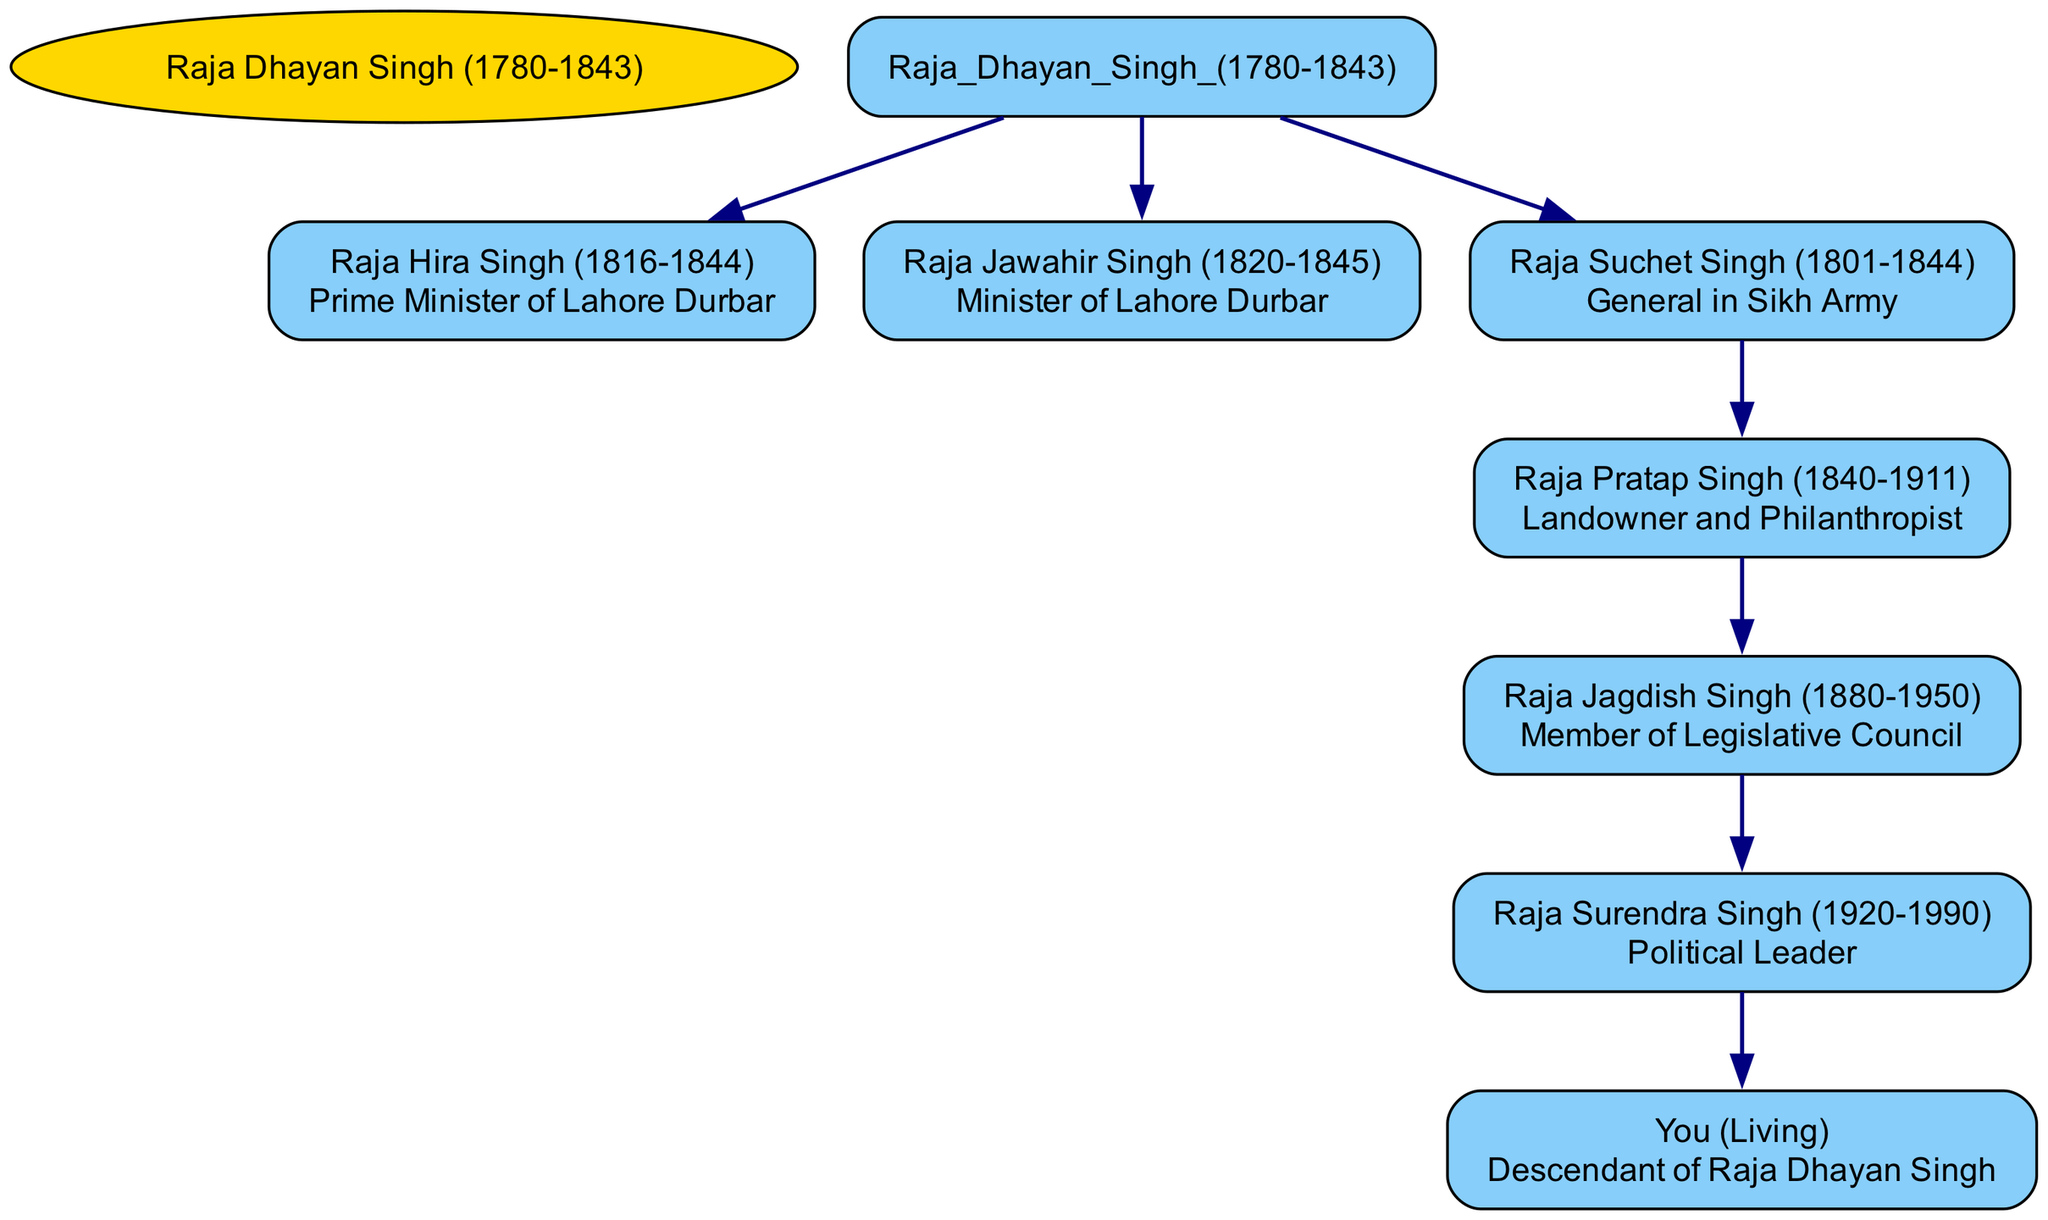What is the title of Raja Hira Singh? Raja Hira Singh is listed in the diagram as "Prime Minister of Lahore Durbar," which is the title given to him.
Answer: Prime Minister of Lahore Durbar How many children did Raja Suchet Singh have? By examining the diagram, Raja Suchet Singh has one child, Raja Pratap Singh, indicated in the diagram under his lineage.
Answer: 1 Who is the immediate descendant of Raja Jagdish Singh? The diagram shows that Raja Surendra Singh is the child of Raja Jagdish Singh, making him the immediate descendant in this lineage.
Answer: Raja Surendra Singh What role did Raja Jawahir Singh hold? The diagram indicates that Raja Jawahir Singh was the "Minister of Lahore Durbar," denoting his position within the royal structure.
Answer: Minister of Lahore Durbar Which descendant of Raja Dhayan Singh is a Political Leader? From the family tree, Raja Surendra Singh is defined as a "Political Leader," establishing his role among the descendants of Raja Dhayan Singh.
Answer: Raja Surendra Singh How many titles are associated with Raja Dhayan Singh's children? In total, Raja Dhayan Singh's children hold three distinct titles: "Prime Minister of Lahore Durbar," "Minister of Lahore Durbar," and "General in Sikh Army." Thus, adding gives a count of distinct titles.
Answer: 3 What is the relationship between Raja Pratap Singh and Raja Jagdish Singh? The diagram shows that Raja Pratap Singh is the father of Raja Jagdish Singh, establishing a direct father-son relationship between them.
Answer: Father Which child of Raja Suchet Singh became a philanthropist? The diagram indicates that Raja Pratap Singh, the child of Raja Suchet Singh, is recognized as a "Landowner and Philanthropist," identifying his philanthropic achievement.
Answer: Raja Pratap Singh What is the birth year of Raja Surendra Singh? According to the diagram, the birth year of Raja Surendra Singh is listed as "1920," providing a specific year associated with him.
Answer: 1920 Which descendant of Raja Dhayan Singh is living? The family tree specifies that "You" is the living descendant of Raja Dhayan Singh, representing the current generation in the lineage.
Answer: You 